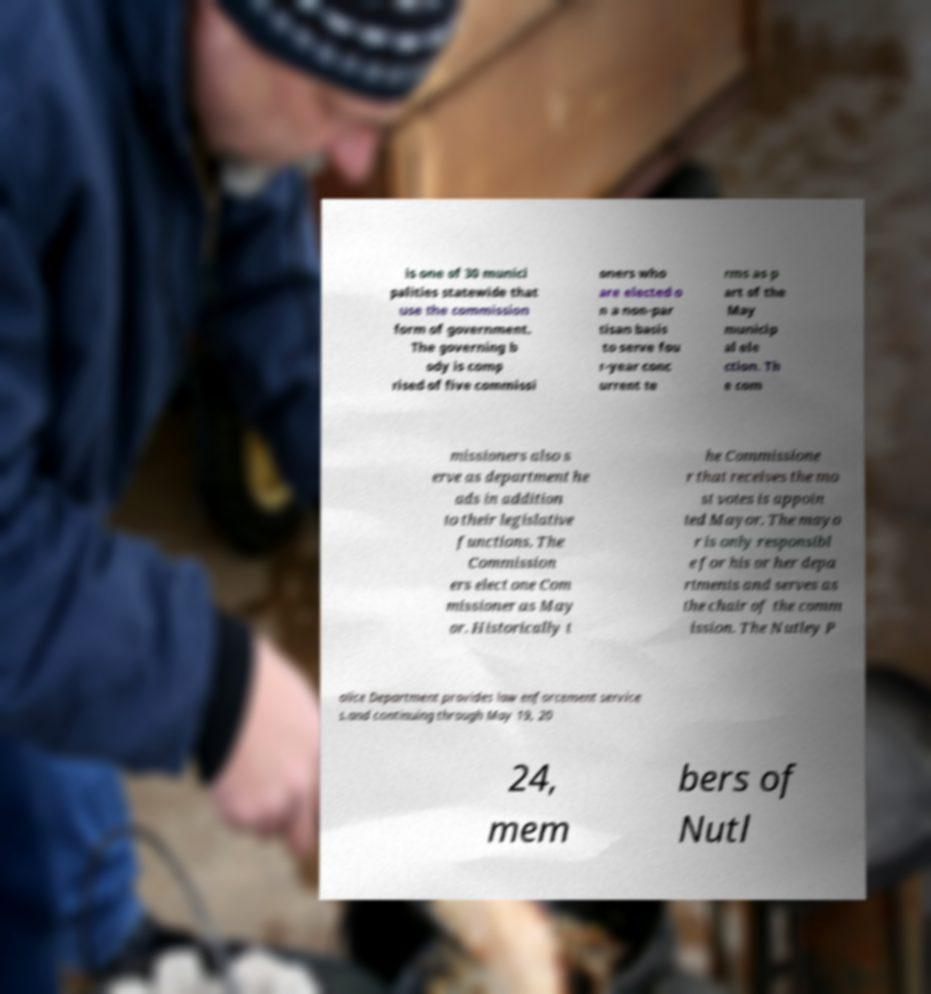Please identify and transcribe the text found in this image. is one of 30 munici palities statewide that use the commission form of government. The governing b ody is comp rised of five commissi oners who are elected o n a non-par tisan basis to serve fou r-year conc urrent te rms as p art of the May municip al ele ction. Th e com missioners also s erve as department he ads in addition to their legislative functions. The Commission ers elect one Com missioner as May or. Historically t he Commissione r that receives the mo st votes is appoin ted Mayor. The mayo r is only responsibl e for his or her depa rtments and serves as the chair of the comm ission. The Nutley P olice Department provides law enforcement service s.and continuing through May 19, 20 24, mem bers of Nutl 